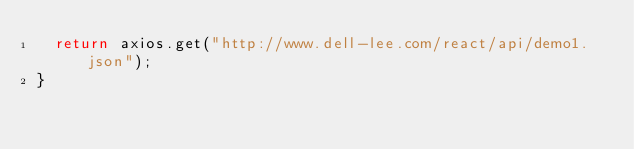Convert code to text. <code><loc_0><loc_0><loc_500><loc_500><_JavaScript_>  return axios.get("http://www.dell-lee.com/react/api/demo1.json");
}
</code> 